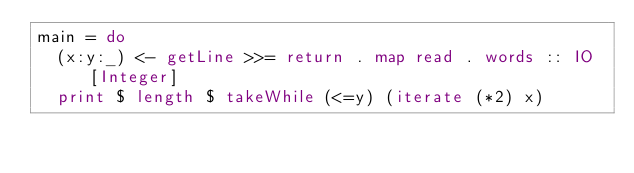Convert code to text. <code><loc_0><loc_0><loc_500><loc_500><_Haskell_>main = do
  (x:y:_) <- getLine >>= return . map read . words :: IO [Integer]
  print $ length $ takeWhile (<=y) (iterate (*2) x)
</code> 